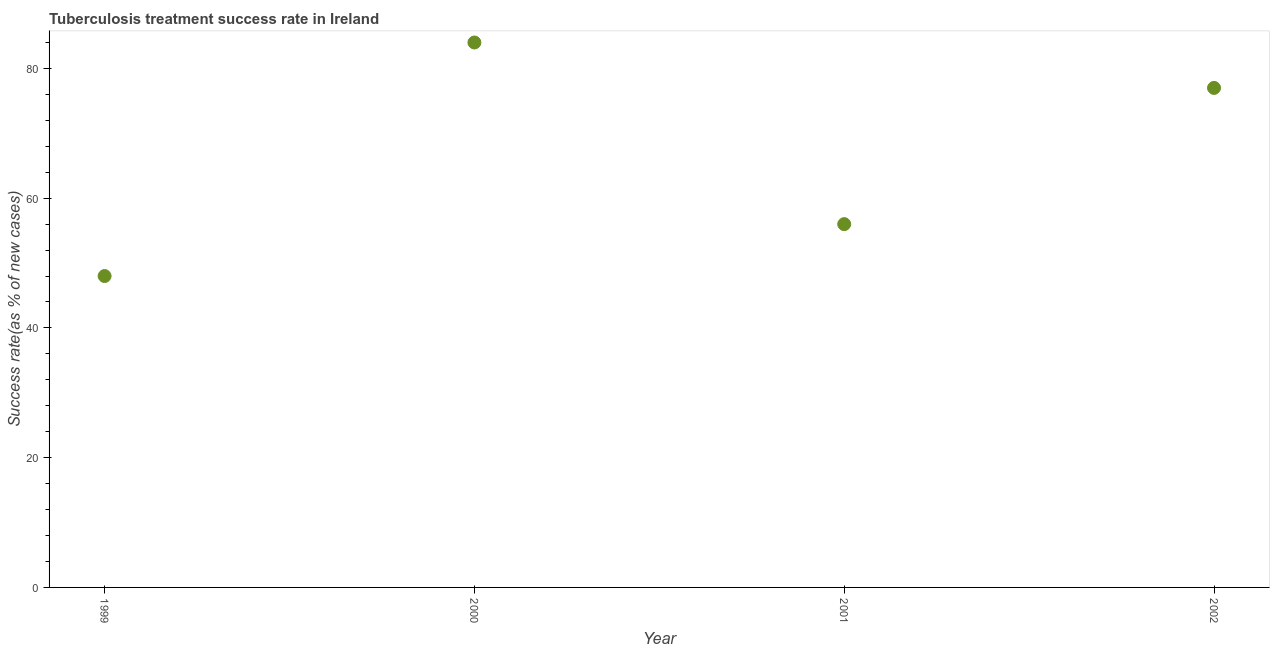What is the tuberculosis treatment success rate in 1999?
Give a very brief answer. 48. Across all years, what is the maximum tuberculosis treatment success rate?
Offer a very short reply. 84. Across all years, what is the minimum tuberculosis treatment success rate?
Offer a terse response. 48. What is the sum of the tuberculosis treatment success rate?
Provide a short and direct response. 265. What is the difference between the tuberculosis treatment success rate in 2001 and 2002?
Offer a very short reply. -21. What is the average tuberculosis treatment success rate per year?
Offer a terse response. 66.25. What is the median tuberculosis treatment success rate?
Offer a very short reply. 66.5. In how many years, is the tuberculosis treatment success rate greater than 68 %?
Provide a short and direct response. 2. Do a majority of the years between 2001 and 2000 (inclusive) have tuberculosis treatment success rate greater than 52 %?
Provide a succinct answer. No. What is the ratio of the tuberculosis treatment success rate in 1999 to that in 2000?
Provide a succinct answer. 0.57. Is the tuberculosis treatment success rate in 1999 less than that in 2002?
Keep it short and to the point. Yes. Is the sum of the tuberculosis treatment success rate in 2001 and 2002 greater than the maximum tuberculosis treatment success rate across all years?
Offer a very short reply. Yes. What is the difference between the highest and the lowest tuberculosis treatment success rate?
Your answer should be compact. 36. In how many years, is the tuberculosis treatment success rate greater than the average tuberculosis treatment success rate taken over all years?
Keep it short and to the point. 2. Does the tuberculosis treatment success rate monotonically increase over the years?
Your answer should be compact. No. How many dotlines are there?
Provide a succinct answer. 1. What is the difference between two consecutive major ticks on the Y-axis?
Keep it short and to the point. 20. Does the graph contain any zero values?
Your answer should be compact. No. What is the title of the graph?
Offer a terse response. Tuberculosis treatment success rate in Ireland. What is the label or title of the Y-axis?
Provide a succinct answer. Success rate(as % of new cases). What is the difference between the Success rate(as % of new cases) in 1999 and 2000?
Your answer should be compact. -36. What is the difference between the Success rate(as % of new cases) in 1999 and 2001?
Offer a terse response. -8. What is the difference between the Success rate(as % of new cases) in 2000 and 2002?
Make the answer very short. 7. What is the difference between the Success rate(as % of new cases) in 2001 and 2002?
Make the answer very short. -21. What is the ratio of the Success rate(as % of new cases) in 1999 to that in 2000?
Your response must be concise. 0.57. What is the ratio of the Success rate(as % of new cases) in 1999 to that in 2001?
Your answer should be very brief. 0.86. What is the ratio of the Success rate(as % of new cases) in 1999 to that in 2002?
Your answer should be very brief. 0.62. What is the ratio of the Success rate(as % of new cases) in 2000 to that in 2001?
Your answer should be compact. 1.5. What is the ratio of the Success rate(as % of new cases) in 2000 to that in 2002?
Keep it short and to the point. 1.09. What is the ratio of the Success rate(as % of new cases) in 2001 to that in 2002?
Make the answer very short. 0.73. 